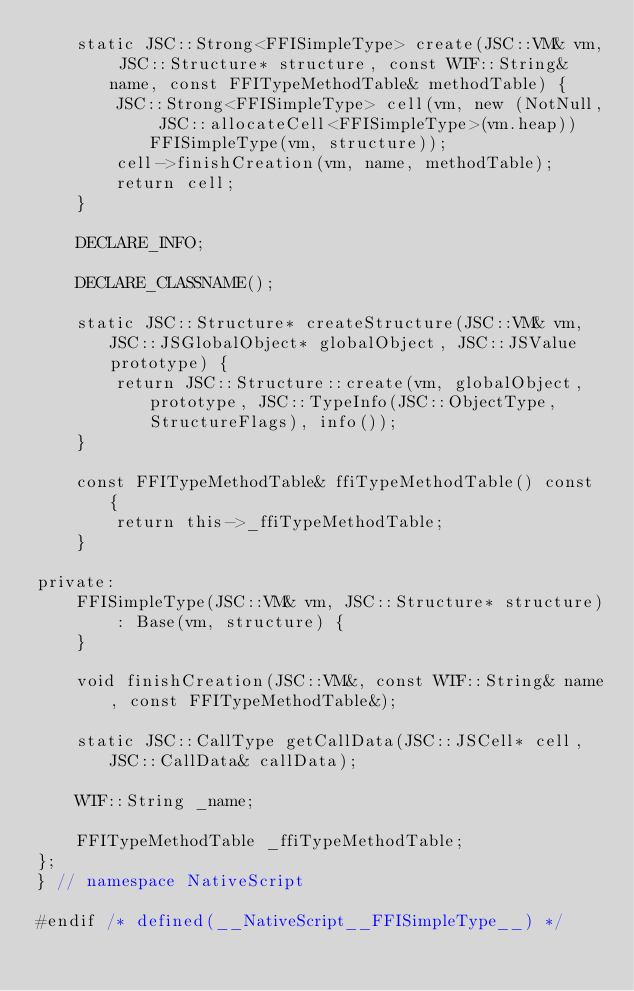Convert code to text. <code><loc_0><loc_0><loc_500><loc_500><_C_>    static JSC::Strong<FFISimpleType> create(JSC::VM& vm, JSC::Structure* structure, const WTF::String& name, const FFITypeMethodTable& methodTable) {
        JSC::Strong<FFISimpleType> cell(vm, new (NotNull, JSC::allocateCell<FFISimpleType>(vm.heap)) FFISimpleType(vm, structure));
        cell->finishCreation(vm, name, methodTable);
        return cell;
    }

    DECLARE_INFO;

    DECLARE_CLASSNAME();

    static JSC::Structure* createStructure(JSC::VM& vm, JSC::JSGlobalObject* globalObject, JSC::JSValue prototype) {
        return JSC::Structure::create(vm, globalObject, prototype, JSC::TypeInfo(JSC::ObjectType, StructureFlags), info());
    }

    const FFITypeMethodTable& ffiTypeMethodTable() const {
        return this->_ffiTypeMethodTable;
    }

private:
    FFISimpleType(JSC::VM& vm, JSC::Structure* structure)
        : Base(vm, structure) {
    }

    void finishCreation(JSC::VM&, const WTF::String& name, const FFITypeMethodTable&);

    static JSC::CallType getCallData(JSC::JSCell* cell, JSC::CallData& callData);

    WTF::String _name;

    FFITypeMethodTable _ffiTypeMethodTable;
};
} // namespace NativeScript

#endif /* defined(__NativeScript__FFISimpleType__) */
</code> 